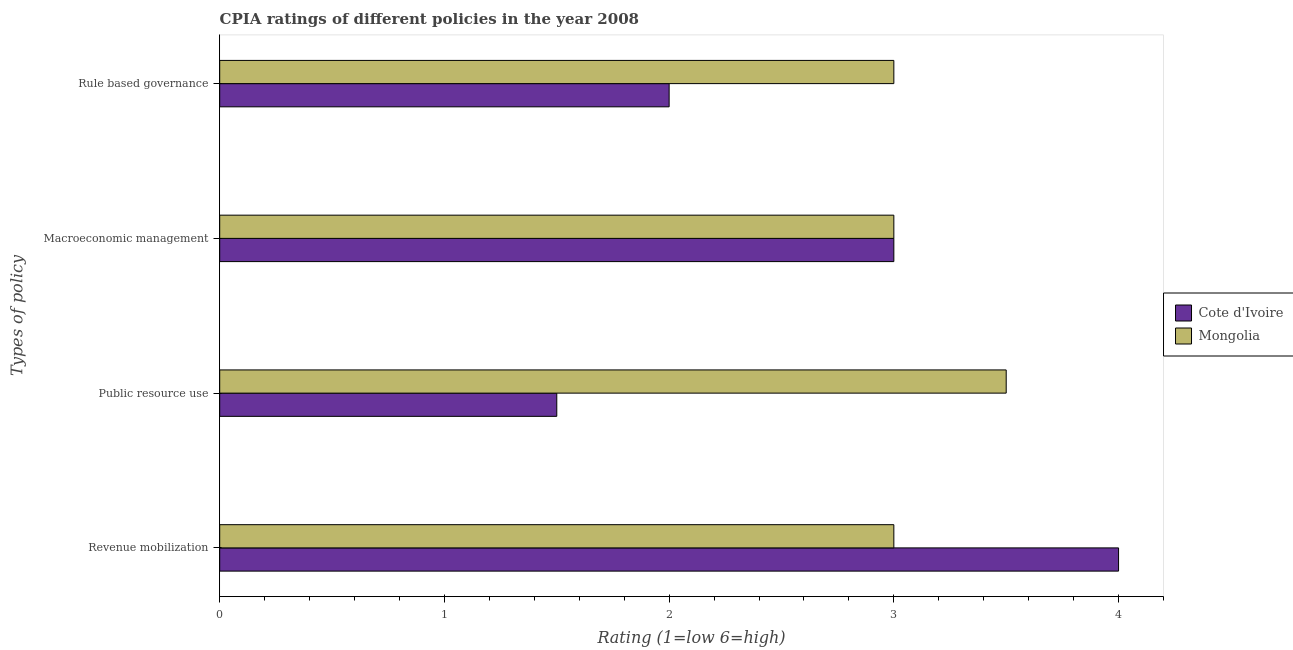How many groups of bars are there?
Provide a short and direct response. 4. Are the number of bars on each tick of the Y-axis equal?
Keep it short and to the point. Yes. How many bars are there on the 1st tick from the top?
Offer a very short reply. 2. What is the label of the 2nd group of bars from the top?
Keep it short and to the point. Macroeconomic management. What is the cpia rating of macroeconomic management in Mongolia?
Offer a terse response. 3. Across all countries, what is the minimum cpia rating of revenue mobilization?
Your answer should be very brief. 3. In which country was the cpia rating of macroeconomic management maximum?
Give a very brief answer. Cote d'Ivoire. In which country was the cpia rating of macroeconomic management minimum?
Your answer should be compact. Cote d'Ivoire. What is the total cpia rating of rule based governance in the graph?
Provide a short and direct response. 5. What is the difference between the cpia rating of macroeconomic management in Mongolia and that in Cote d'Ivoire?
Offer a terse response. 0. What is the difference between the cpia rating of revenue mobilization and cpia rating of macroeconomic management in Mongolia?
Make the answer very short. 0. What is the ratio of the cpia rating of revenue mobilization in Mongolia to that in Cote d'Ivoire?
Offer a terse response. 0.75. Is the cpia rating of macroeconomic management in Mongolia less than that in Cote d'Ivoire?
Provide a succinct answer. No. Is the sum of the cpia rating of macroeconomic management in Cote d'Ivoire and Mongolia greater than the maximum cpia rating of public resource use across all countries?
Provide a succinct answer. Yes. What does the 1st bar from the top in Macroeconomic management represents?
Your response must be concise. Mongolia. What does the 1st bar from the bottom in Macroeconomic management represents?
Give a very brief answer. Cote d'Ivoire. Is it the case that in every country, the sum of the cpia rating of revenue mobilization and cpia rating of public resource use is greater than the cpia rating of macroeconomic management?
Your answer should be compact. Yes. How many bars are there?
Provide a short and direct response. 8. Are all the bars in the graph horizontal?
Give a very brief answer. Yes. What is the difference between two consecutive major ticks on the X-axis?
Ensure brevity in your answer.  1. How many legend labels are there?
Provide a succinct answer. 2. What is the title of the graph?
Give a very brief answer. CPIA ratings of different policies in the year 2008. Does "El Salvador" appear as one of the legend labels in the graph?
Offer a very short reply. No. What is the label or title of the Y-axis?
Your answer should be very brief. Types of policy. What is the Rating (1=low 6=high) in Mongolia in Revenue mobilization?
Ensure brevity in your answer.  3. What is the Rating (1=low 6=high) of Mongolia in Public resource use?
Ensure brevity in your answer.  3.5. What is the Rating (1=low 6=high) in Cote d'Ivoire in Macroeconomic management?
Your answer should be very brief. 3. What is the Rating (1=low 6=high) in Cote d'Ivoire in Rule based governance?
Offer a terse response. 2. What is the Rating (1=low 6=high) of Mongolia in Rule based governance?
Provide a succinct answer. 3. What is the difference between the Rating (1=low 6=high) in Mongolia in Revenue mobilization and that in Public resource use?
Ensure brevity in your answer.  -0.5. What is the difference between the Rating (1=low 6=high) in Mongolia in Revenue mobilization and that in Macroeconomic management?
Your answer should be compact. 0. What is the difference between the Rating (1=low 6=high) of Cote d'Ivoire in Revenue mobilization and that in Rule based governance?
Keep it short and to the point. 2. What is the difference between the Rating (1=low 6=high) of Cote d'Ivoire in Public resource use and that in Macroeconomic management?
Offer a very short reply. -1.5. What is the difference between the Rating (1=low 6=high) of Cote d'Ivoire in Public resource use and that in Rule based governance?
Your answer should be very brief. -0.5. What is the difference between the Rating (1=low 6=high) in Cote d'Ivoire in Revenue mobilization and the Rating (1=low 6=high) in Mongolia in Macroeconomic management?
Keep it short and to the point. 1. What is the difference between the Rating (1=low 6=high) of Cote d'Ivoire in Revenue mobilization and the Rating (1=low 6=high) of Mongolia in Rule based governance?
Provide a short and direct response. 1. What is the difference between the Rating (1=low 6=high) of Cote d'Ivoire in Macroeconomic management and the Rating (1=low 6=high) of Mongolia in Rule based governance?
Your answer should be very brief. 0. What is the average Rating (1=low 6=high) of Cote d'Ivoire per Types of policy?
Offer a very short reply. 2.62. What is the average Rating (1=low 6=high) of Mongolia per Types of policy?
Offer a terse response. 3.12. What is the ratio of the Rating (1=low 6=high) of Cote d'Ivoire in Revenue mobilization to that in Public resource use?
Your answer should be very brief. 2.67. What is the ratio of the Rating (1=low 6=high) of Mongolia in Revenue mobilization to that in Public resource use?
Keep it short and to the point. 0.86. What is the ratio of the Rating (1=low 6=high) in Cote d'Ivoire in Public resource use to that in Rule based governance?
Provide a short and direct response. 0.75. What is the ratio of the Rating (1=low 6=high) in Cote d'Ivoire in Macroeconomic management to that in Rule based governance?
Offer a very short reply. 1.5. What is the ratio of the Rating (1=low 6=high) in Mongolia in Macroeconomic management to that in Rule based governance?
Provide a short and direct response. 1. What is the difference between the highest and the second highest Rating (1=low 6=high) of Mongolia?
Your answer should be very brief. 0.5. What is the difference between the highest and the lowest Rating (1=low 6=high) in Mongolia?
Give a very brief answer. 0.5. 